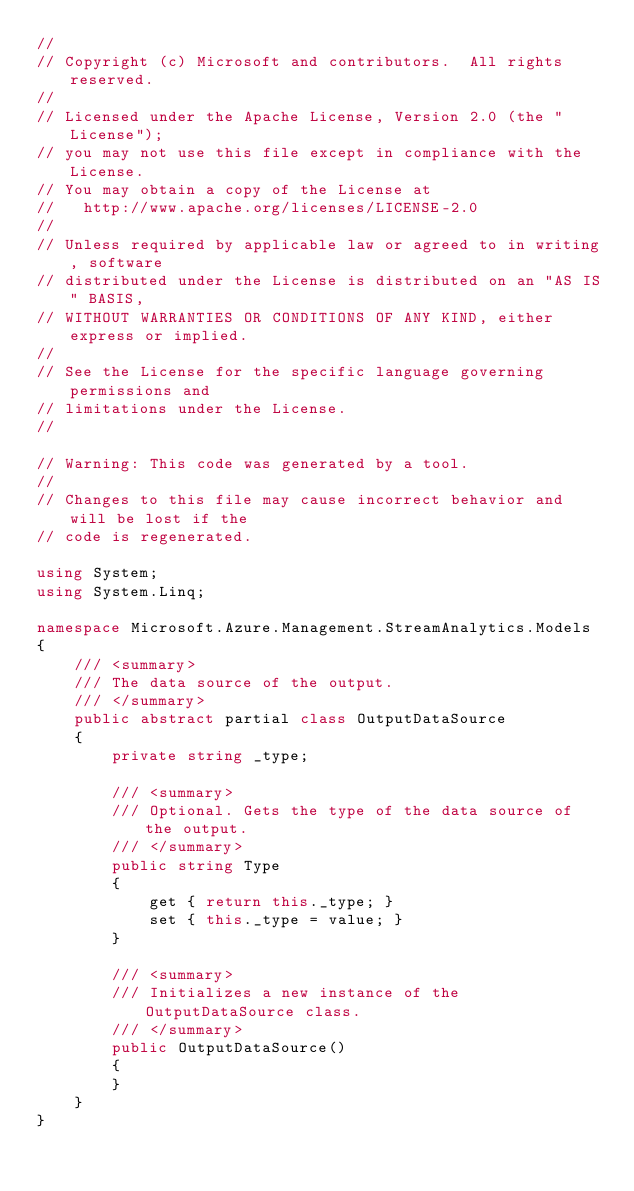Convert code to text. <code><loc_0><loc_0><loc_500><loc_500><_C#_>// 
// Copyright (c) Microsoft and contributors.  All rights reserved.
// 
// Licensed under the Apache License, Version 2.0 (the "License");
// you may not use this file except in compliance with the License.
// You may obtain a copy of the License at
//   http://www.apache.org/licenses/LICENSE-2.0
// 
// Unless required by applicable law or agreed to in writing, software
// distributed under the License is distributed on an "AS IS" BASIS,
// WITHOUT WARRANTIES OR CONDITIONS OF ANY KIND, either express or implied.
// 
// See the License for the specific language governing permissions and
// limitations under the License.
// 

// Warning: This code was generated by a tool.
// 
// Changes to this file may cause incorrect behavior and will be lost if the
// code is regenerated.

using System;
using System.Linq;

namespace Microsoft.Azure.Management.StreamAnalytics.Models
{
    /// <summary>
    /// The data source of the output.
    /// </summary>
    public abstract partial class OutputDataSource
    {
        private string _type;
        
        /// <summary>
        /// Optional. Gets the type of the data source of the output.
        /// </summary>
        public string Type
        {
            get { return this._type; }
            set { this._type = value; }
        }
        
        /// <summary>
        /// Initializes a new instance of the OutputDataSource class.
        /// </summary>
        public OutputDataSource()
        {
        }
    }
}
</code> 